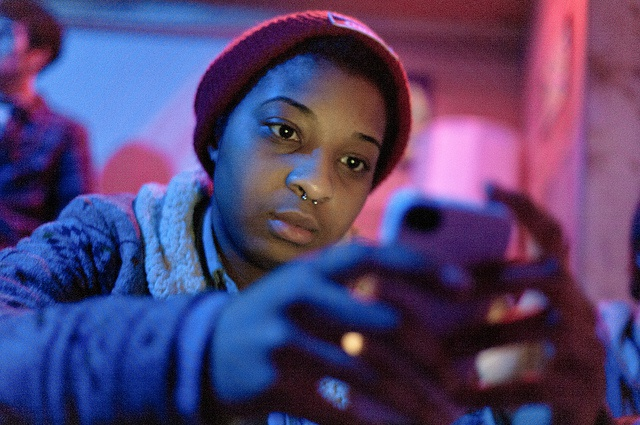Describe the objects in this image and their specific colors. I can see people in purple, black, blue, navy, and maroon tones, cell phone in purple, black, navy, and violet tones, and people in purple, black, navy, and darkblue tones in this image. 